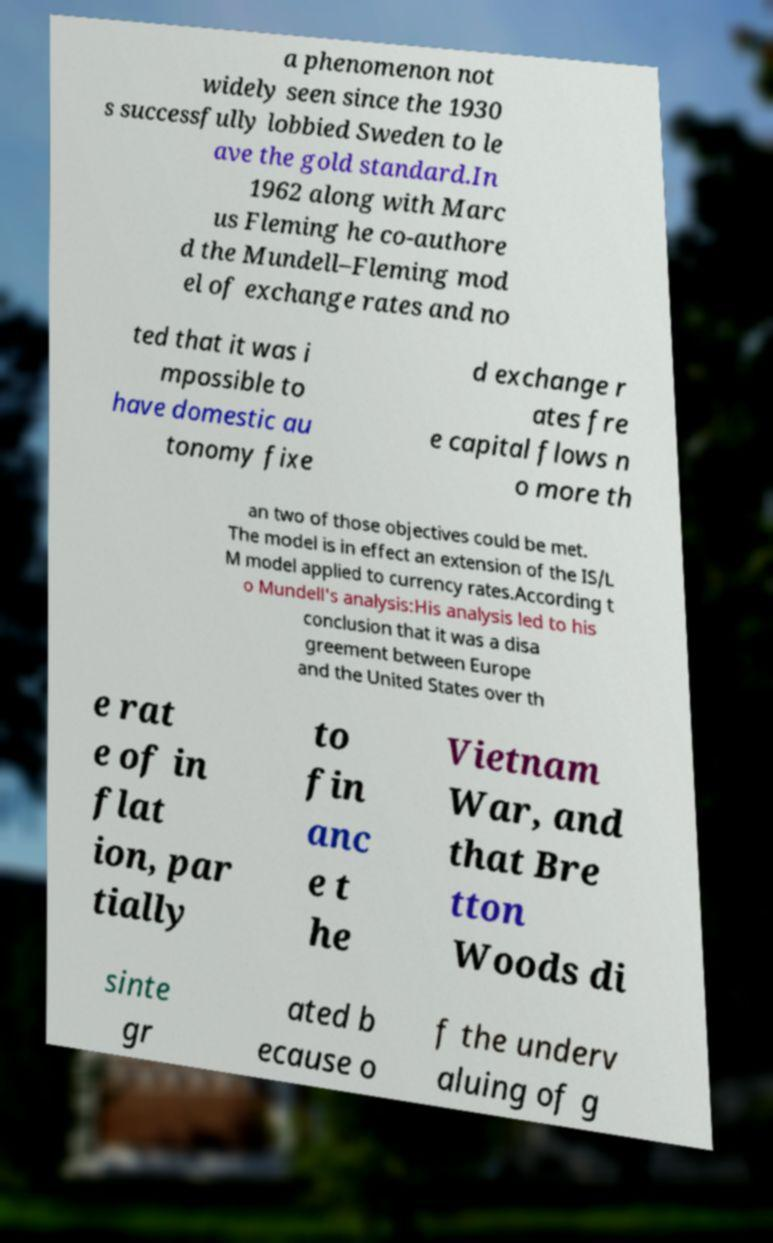There's text embedded in this image that I need extracted. Can you transcribe it verbatim? a phenomenon not widely seen since the 1930 s successfully lobbied Sweden to le ave the gold standard.In 1962 along with Marc us Fleming he co-authore d the Mundell–Fleming mod el of exchange rates and no ted that it was i mpossible to have domestic au tonomy fixe d exchange r ates fre e capital flows n o more th an two of those objectives could be met. The model is in effect an extension of the IS/L M model applied to currency rates.According t o Mundell's analysis:His analysis led to his conclusion that it was a disa greement between Europe and the United States over th e rat e of in flat ion, par tially to fin anc e t he Vietnam War, and that Bre tton Woods di sinte gr ated b ecause o f the underv aluing of g 